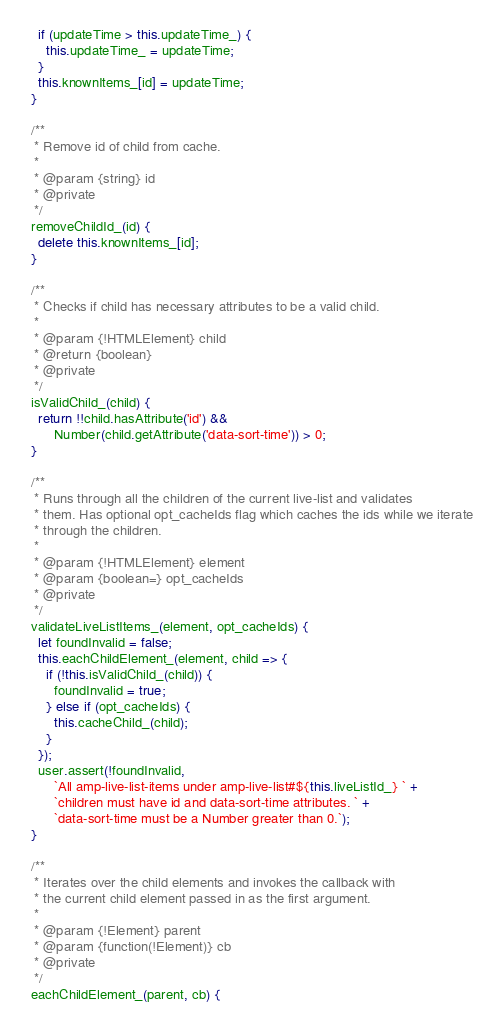<code> <loc_0><loc_0><loc_500><loc_500><_JavaScript_>    if (updateTime > this.updateTime_) {
      this.updateTime_ = updateTime;
    }
    this.knownItems_[id] = updateTime;
  }

  /**
   * Remove id of child from cache.
   *
   * @param {string} id
   * @private
   */
  removeChildId_(id) {
    delete this.knownItems_[id];
  }

  /**
   * Checks if child has necessary attributes to be a valid child.
   *
   * @param {!HTMLElement} child
   * @return {boolean}
   * @private
   */
  isValidChild_(child) {
    return !!child.hasAttribute('id') &&
        Number(child.getAttribute('data-sort-time')) > 0;
  }

  /**
   * Runs through all the children of the current live-list and validates
   * them. Has optional opt_cacheIds flag which caches the ids while we iterate
   * through the children.
   *
   * @param {!HTMLElement} element
   * @param {boolean=} opt_cacheIds
   * @private
   */
  validateLiveListItems_(element, opt_cacheIds) {
    let foundInvalid = false;
    this.eachChildElement_(element, child => {
      if (!this.isValidChild_(child)) {
        foundInvalid = true;
      } else if (opt_cacheIds) {
        this.cacheChild_(child);
      }
    });
    user.assert(!foundInvalid,
        `All amp-live-list-items under amp-live-list#${this.liveListId_} ` +
        `children must have id and data-sort-time attributes. ` +
        `data-sort-time must be a Number greater than 0.`);
  }

  /**
   * Iterates over the child elements and invokes the callback with
   * the current child element passed in as the first argument.
   *
   * @param {!Element} parent
   * @param {function(!Element)} cb
   * @private
   */
  eachChildElement_(parent, cb) {</code> 